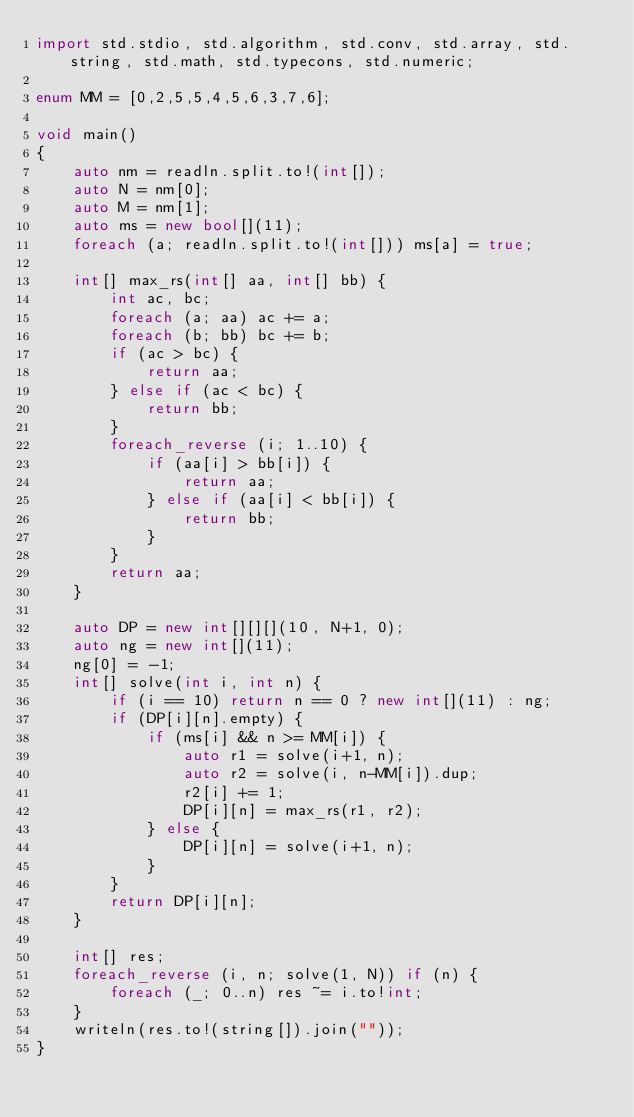Convert code to text. <code><loc_0><loc_0><loc_500><loc_500><_D_>import std.stdio, std.algorithm, std.conv, std.array, std.string, std.math, std.typecons, std.numeric;

enum MM = [0,2,5,5,4,5,6,3,7,6];

void main()
{
    auto nm = readln.split.to!(int[]);
    auto N = nm[0];
    auto M = nm[1];
    auto ms = new bool[](11);
    foreach (a; readln.split.to!(int[])) ms[a] = true;

    int[] max_rs(int[] aa, int[] bb) {
        int ac, bc;
        foreach (a; aa) ac += a;
        foreach (b; bb) bc += b;
        if (ac > bc) {
            return aa;
        } else if (ac < bc) {
            return bb;
        }
        foreach_reverse (i; 1..10) {
            if (aa[i] > bb[i]) {
                return aa;
            } else if (aa[i] < bb[i]) {
                return bb;
            }
        }
        return aa;
    }

    auto DP = new int[][][](10, N+1, 0);
    auto ng = new int[](11);
    ng[0] = -1;
    int[] solve(int i, int n) {
        if (i == 10) return n == 0 ? new int[](11) : ng;
        if (DP[i][n].empty) {
            if (ms[i] && n >= MM[i]) {
                auto r1 = solve(i+1, n);
                auto r2 = solve(i, n-MM[i]).dup;
                r2[i] += 1;
                DP[i][n] = max_rs(r1, r2);
            } else {
                DP[i][n] = solve(i+1, n);
            }
        }
        return DP[i][n];
    }

    int[] res;
    foreach_reverse (i, n; solve(1, N)) if (n) {
        foreach (_; 0..n) res ~= i.to!int;
    }
    writeln(res.to!(string[]).join(""));
}</code> 